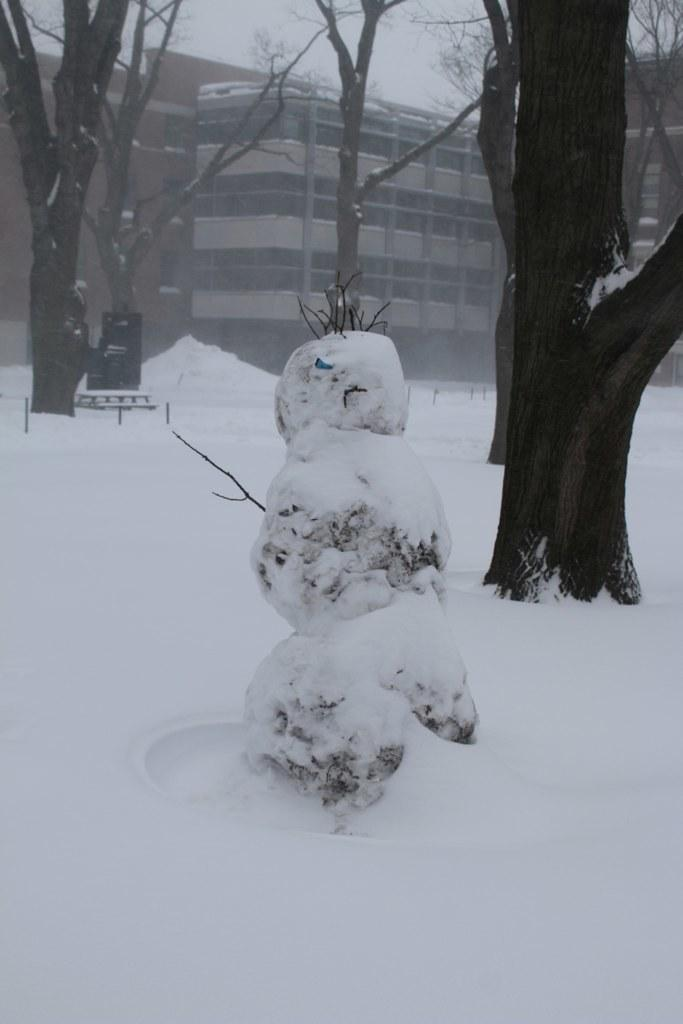What is visible on the ground in the image? The ground is visible in the image. What is covering some of the objects in the image? There are objects covered with snow in the image. What type of natural vegetation can be seen in the image? There are trees in the image. What type of man-made structures are present in the image? There are buildings in the image. What is visible above the ground and objects in the image? The sky is visible in the image. What type of education does the manager of the sink in the image have? There is no manager or sink present in the image. What type of sink is visible in the image? There is no sink present in the image. 